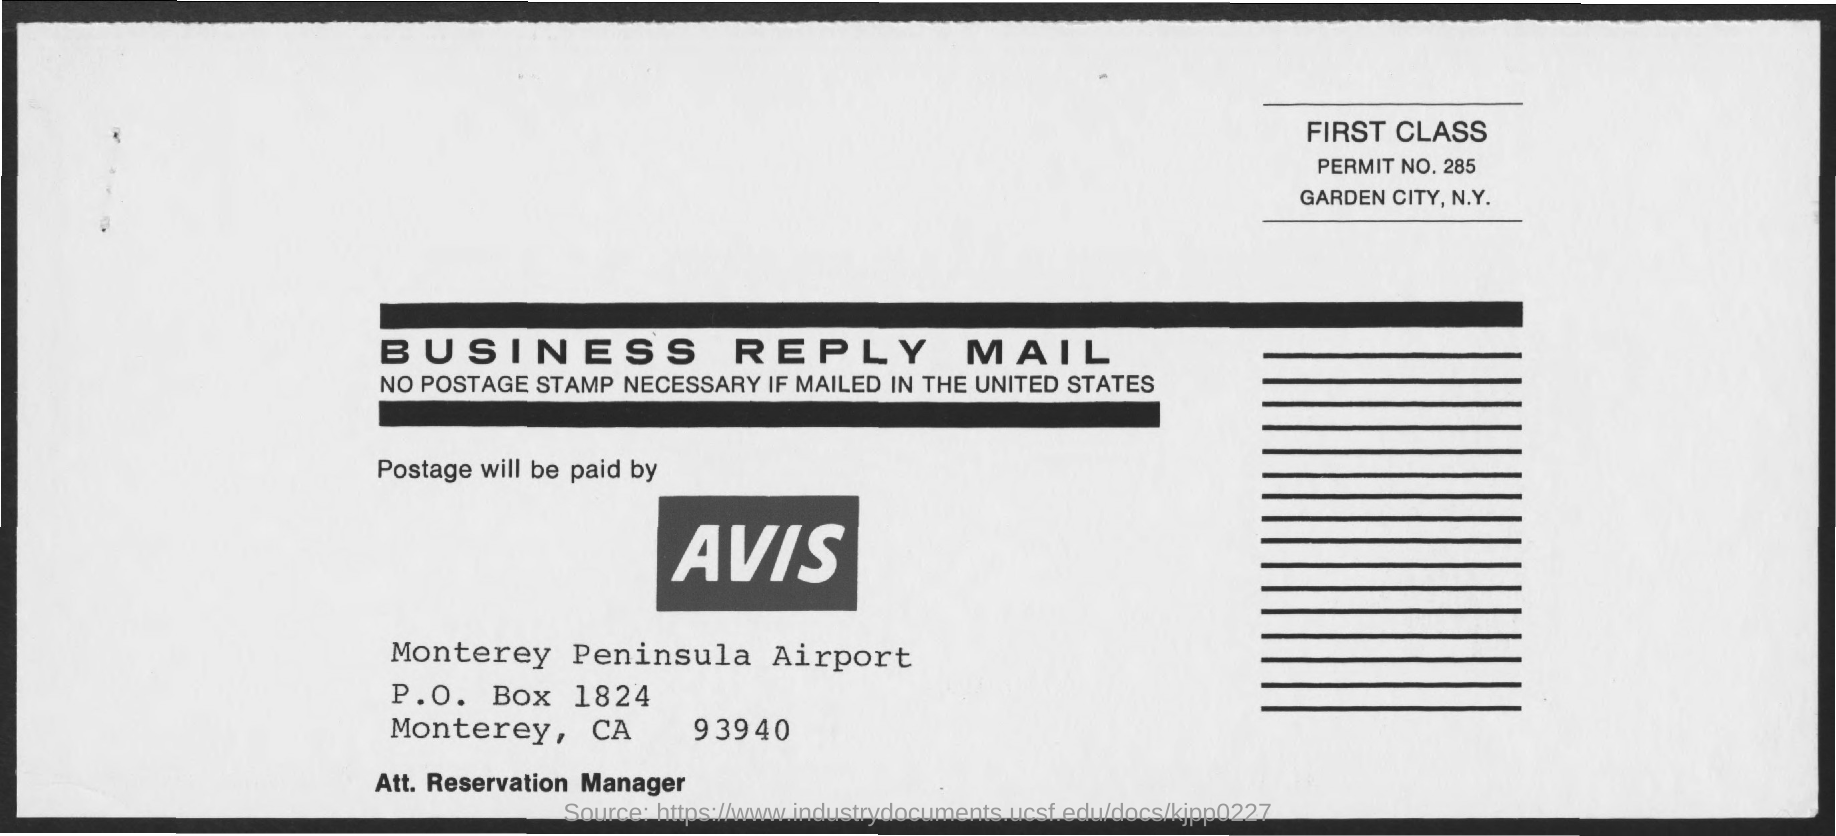What is the name of the airport mentioned ?
Offer a very short reply. Monterey peninsula airport. What is the p.o.box no. mentioned ?
Provide a succinct answer. 1824. What is the permit no. mentioned ?
Provide a succinct answer. 285. What is the type of the class mentioned ?
Make the answer very short. First class. By whom the postage will be paid ?
Offer a terse response. AVIS. 